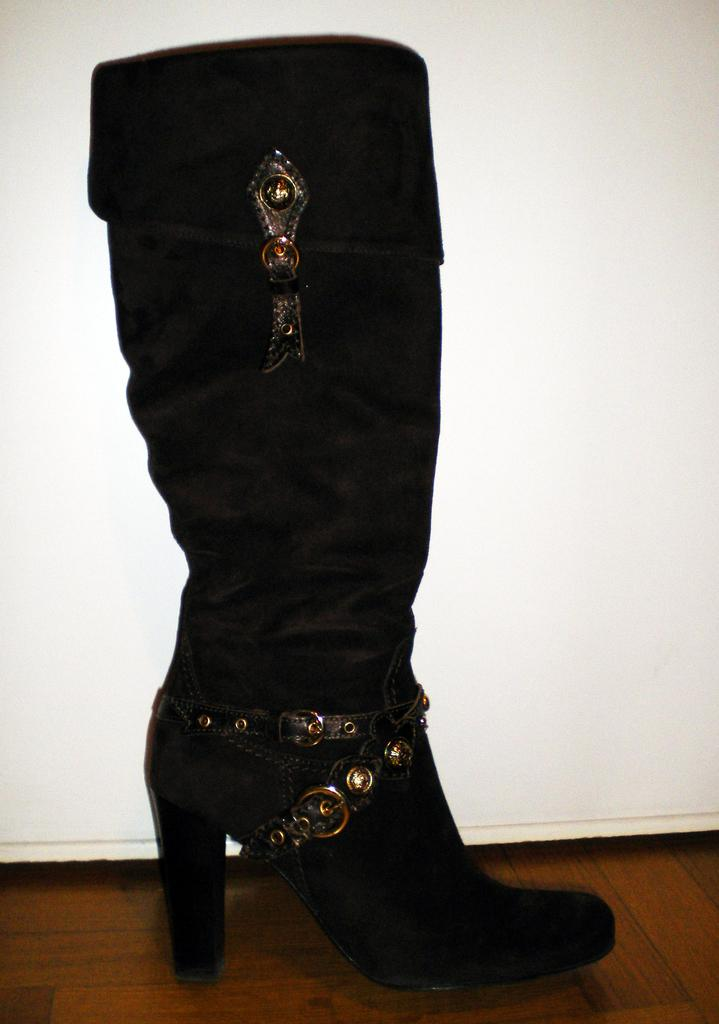What is placed in the center of the image? There is a shoe placed in the center of the image. Can you describe the position of the shoe in the image? The shoe is placed on the ground. What is visible in the background of the image? There is a wall in the background of the image. What type of stove can be seen in the image? There is no stove present in the image. How many cars are visible in the image? There are no cars visible in the image. What type of coil is wrapped around the shoe in the image? There is no coil present in the image; it features a shoe placed on the ground. 